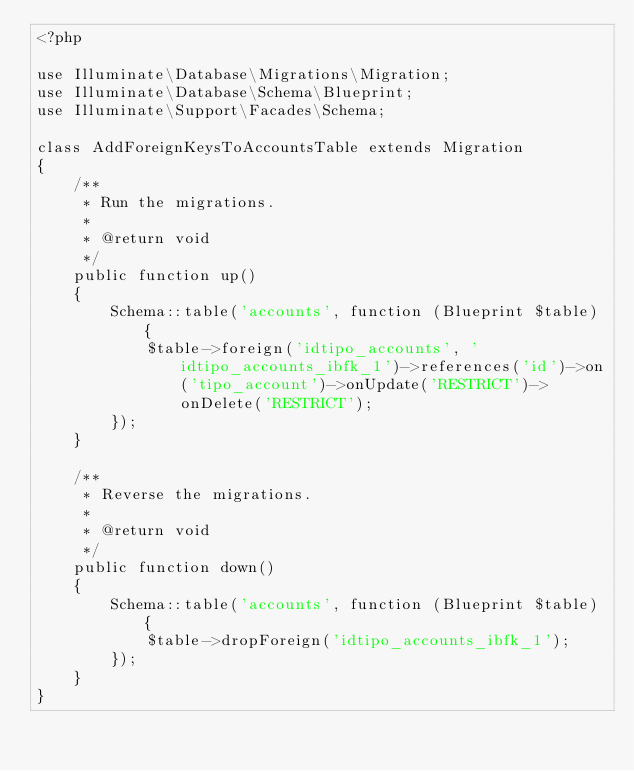<code> <loc_0><loc_0><loc_500><loc_500><_PHP_><?php

use Illuminate\Database\Migrations\Migration;
use Illuminate\Database\Schema\Blueprint;
use Illuminate\Support\Facades\Schema;

class AddForeignKeysToAccountsTable extends Migration
{
    /**
     * Run the migrations.
     *
     * @return void
     */
    public function up()
    {
        Schema::table('accounts', function (Blueprint $table) {
            $table->foreign('idtipo_accounts', 'idtipo_accounts_ibfk_1')->references('id')->on('tipo_account')->onUpdate('RESTRICT')->onDelete('RESTRICT');
        });
    }

    /**
     * Reverse the migrations.
     *
     * @return void
     */
    public function down()
    {
        Schema::table('accounts', function (Blueprint $table) {
            $table->dropForeign('idtipo_accounts_ibfk_1');
        });
    }
}
</code> 